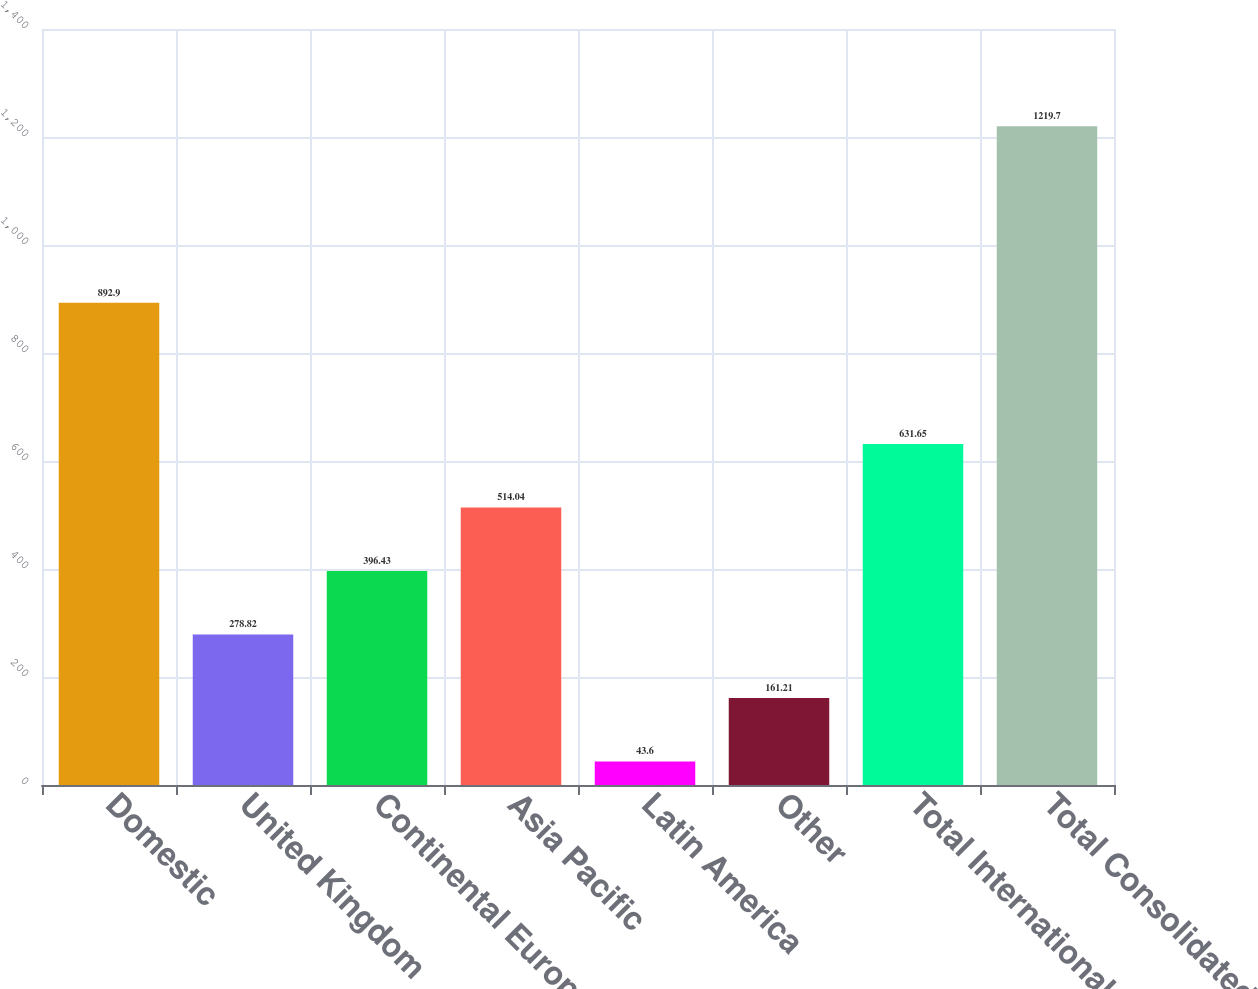Convert chart. <chart><loc_0><loc_0><loc_500><loc_500><bar_chart><fcel>Domestic<fcel>United Kingdom<fcel>Continental Europe<fcel>Asia Pacific<fcel>Latin America<fcel>Other<fcel>Total International<fcel>Total Consolidated<nl><fcel>892.9<fcel>278.82<fcel>396.43<fcel>514.04<fcel>43.6<fcel>161.21<fcel>631.65<fcel>1219.7<nl></chart> 